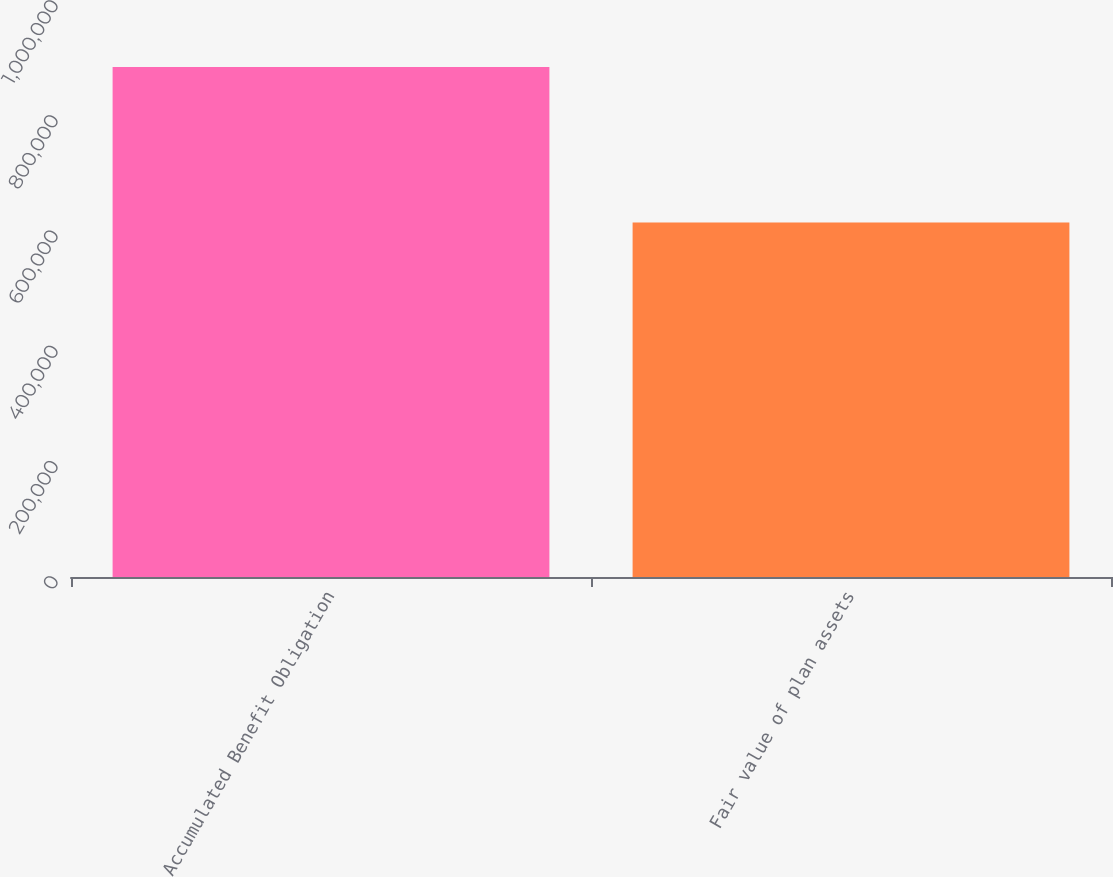<chart> <loc_0><loc_0><loc_500><loc_500><bar_chart><fcel>Accumulated Benefit Obligation<fcel>Fair value of plan assets<nl><fcel>885531<fcel>615563<nl></chart> 